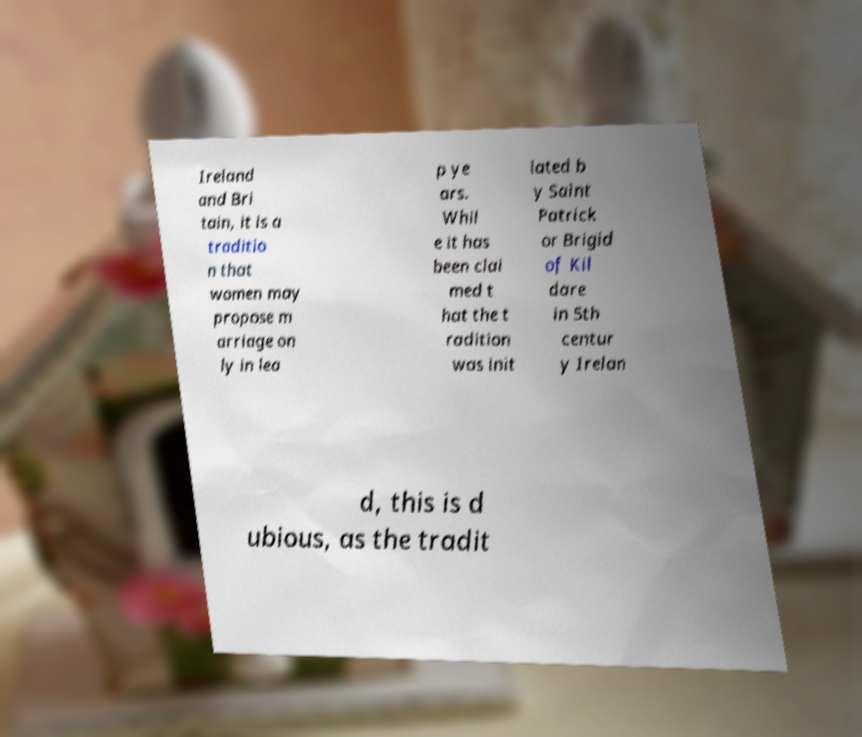Can you read and provide the text displayed in the image?This photo seems to have some interesting text. Can you extract and type it out for me? Ireland and Bri tain, it is a traditio n that women may propose m arriage on ly in lea p ye ars. Whil e it has been clai med t hat the t radition was init iated b y Saint Patrick or Brigid of Kil dare in 5th centur y Irelan d, this is d ubious, as the tradit 